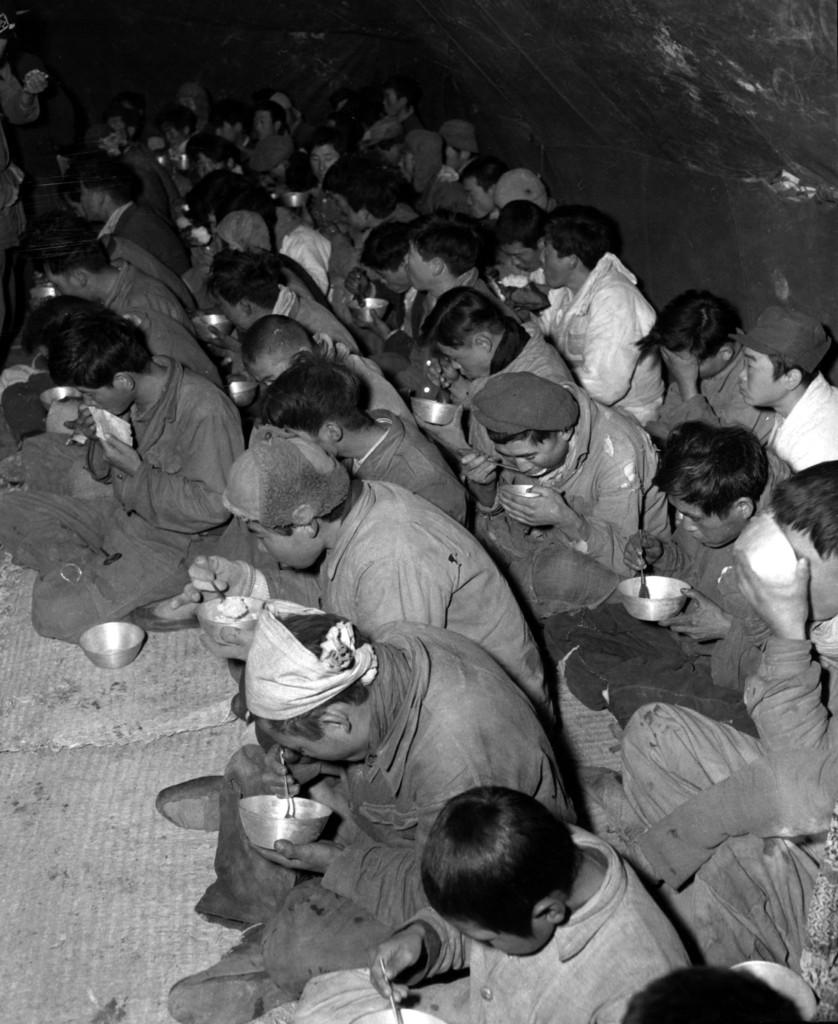How many people are in the image? There is a group of people in the image. What are some people holding in the image? Some people are holding bowls with spoons. What can be seen in the background of the image? There is a wall in the background of the image. What type of stocking is being used by the people in the image? There is no mention of stockings in the image, so it cannot be determined what type of stocking might be used. 